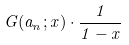Convert formula to latex. <formula><loc_0><loc_0><loc_500><loc_500>G ( a _ { n } ; x ) \cdot \frac { 1 } { 1 - x }</formula> 